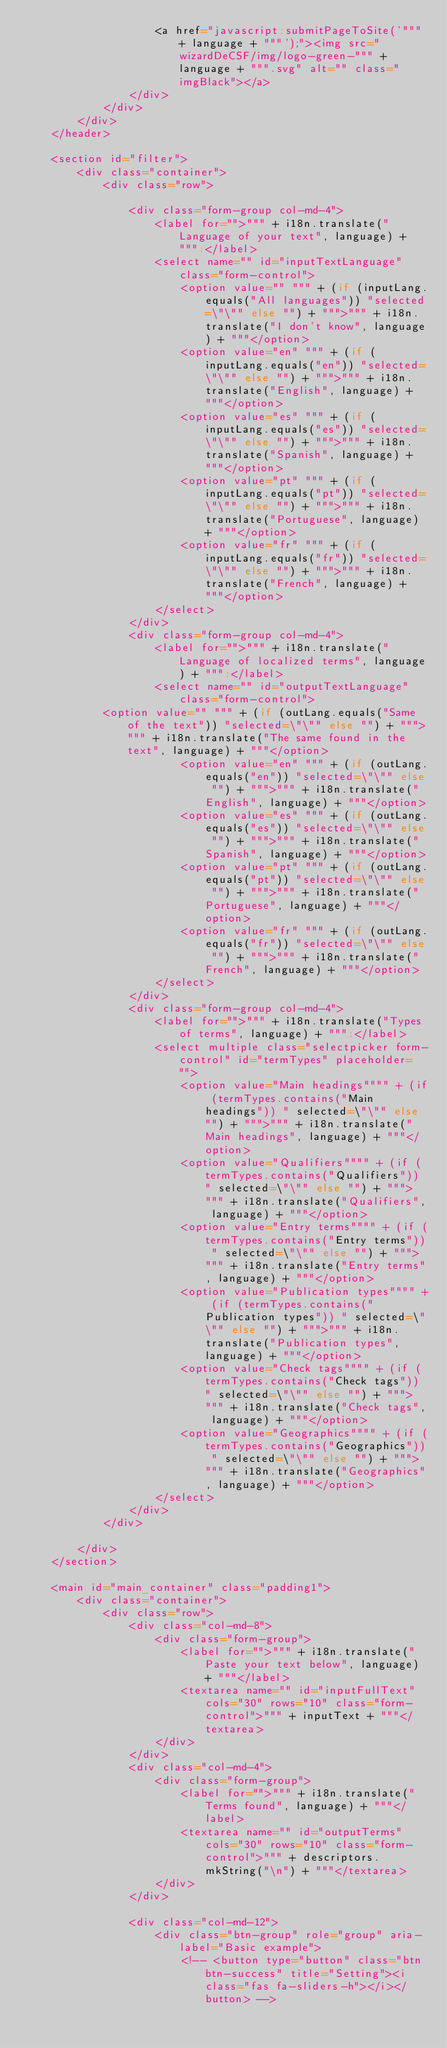Convert code to text. <code><loc_0><loc_0><loc_500><loc_500><_Scala_>					<a href="javascript:submitPageToSite('""" + language + """');"><img src="wizardDeCSF/img/logo-green-""" + language + """.svg" alt="" class="imgBlack"></a>
				</div>
			</div>
		</div>
	</header>

	<section id="filter">
		<div class="container">
			<div class="row">

				<div class="form-group col-md-4">
					<label for="">""" + i18n.translate("Language of your text", language) + """:</label>
					<select name="" id="inputTextLanguage" class="form-control">
						<option value="" """ + (if (inputLang.equals("All languages")) "selected=\"\"" else "") + """>""" + i18n.translate("I don't know", language) + """</option>
						<option value="en" """ + (if (inputLang.equals("en")) "selected=\"\"" else "") + """>""" + i18n.translate("English", language) + """</option>
						<option value="es" """ + (if (inputLang.equals("es")) "selected=\"\"" else "") + """>""" + i18n.translate("Spanish", language) + """</option>
						<option value="pt" """ + (if (inputLang.equals("pt")) "selected=\"\"" else "") + """>""" + i18n.translate("Portuguese", language) + """</option>
						<option value="fr" """ + (if (inputLang.equals("fr")) "selected=\"\"" else "") + """>""" + i18n.translate("French", language) + """</option>
					</select>
				</div>
				<div class="form-group col-md-4">
					<label for="">""" + i18n.translate("Language of localized terms", language) + """:</label>
					<select name="" id="outputTextLanguage" class="form-control">
            <option value="" """ + (if (outLang.equals("Same of the text")) "selected=\"\"" else "") + """>""" + i18n.translate("The same found in the text", language) + """</option>
						<option value="en" """ + (if (outLang.equals("en")) "selected=\"\"" else "") + """>""" + i18n.translate("English", language) + """</option>
						<option value="es" """ + (if (outLang.equals("es")) "selected=\"\"" else "") + """>""" + i18n.translate("Spanish", language) + """</option>
						<option value="pt" """ + (if (outLang.equals("pt")) "selected=\"\"" else "") + """>""" + i18n.translate("Portuguese", language) + """</option>
						<option value="fr" """ + (if (outLang.equals("fr")) "selected=\"\"" else "") + """>""" + i18n.translate("French", language) + """</option>
					</select>
				</div>
				<div class="form-group col-md-4">
					<label for="">""" + i18n.translate("Types of terms", language) + """:</label>
					<select multiple class="selectpicker form-control" id="termTypes" placeholder="">
						<option value="Main headings"""" + (if (termTypes.contains("Main headings")) " selected=\"\"" else "") + """>""" + i18n.translate("Main headings", language) + """</option>
						<option value="Qualifiers"""" + (if (termTypes.contains("Qualifiers")) " selected=\"\"" else "") + """>""" + i18n.translate("Qualifiers", language) + """</option>
						<option value="Entry terms"""" + (if (termTypes.contains("Entry terms")) " selected=\"\"" else "") + """>""" + i18n.translate("Entry terms", language) + """</option>
						<option value="Publication types"""" + (if (termTypes.contains("Publication types")) " selected=\"\"" else "") + """>""" + i18n.translate("Publication types", language) + """</option>
						<option value="Check tags"""" + (if (termTypes.contains("Check tags")) " selected=\"\"" else "") + """>""" + i18n.translate("Check tags", language) + """</option>
						<option value="Geographics"""" + (if (termTypes.contains("Geographics")) " selected=\"\"" else "") + """>""" + i18n.translate("Geographics", language) + """</option>
					</select>
				</div>
			</div>

		</div>
	</section>

	<main id="main_container" class="padding1">
		<div class="container">
			<div class="row">
				<div class="col-md-8">
					<div class="form-group">
						<label for="">""" + i18n.translate("Paste your text below", language) + """</label>
						<textarea name="" id="inputFullText" cols="30" rows="10" class="form-control">""" + inputText + """</textarea>
					</div>
				</div>
				<div class="col-md-4">
					<div class="form-group">
						<label for="">""" + i18n.translate("Terms found", language) + """</label>
						<textarea name="" id="outputTerms" cols="30" rows="10" class="form-control">""" + descriptors.mkString("\n") + """</textarea>
					</div>
				</div>

				<div class="col-md-12">
					<div class="btn-group" role="group" aria-label="Basic example">
						<!-- <button type="button" class="btn btn-success" title="Setting"><i class="fas fa-sliders-h"></i></button> --></code> 